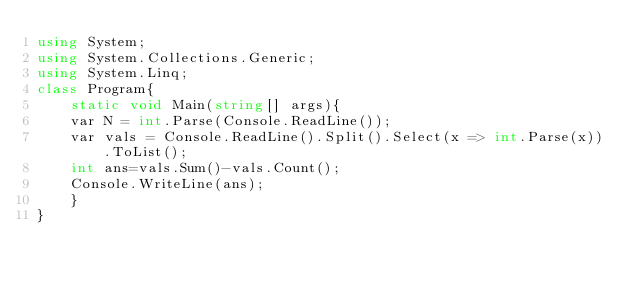Convert code to text. <code><loc_0><loc_0><loc_500><loc_500><_C#_>using System;
using System.Collections.Generic;
using System.Linq;
class Program{
    static void Main(string[] args){
    var N = int.Parse(Console.ReadLine());
    var vals = Console.ReadLine().Split().Select(x => int.Parse(x)).ToList();
    int ans=vals.Sum()-vals.Count();
    Console.WriteLine(ans);
    }
}
</code> 